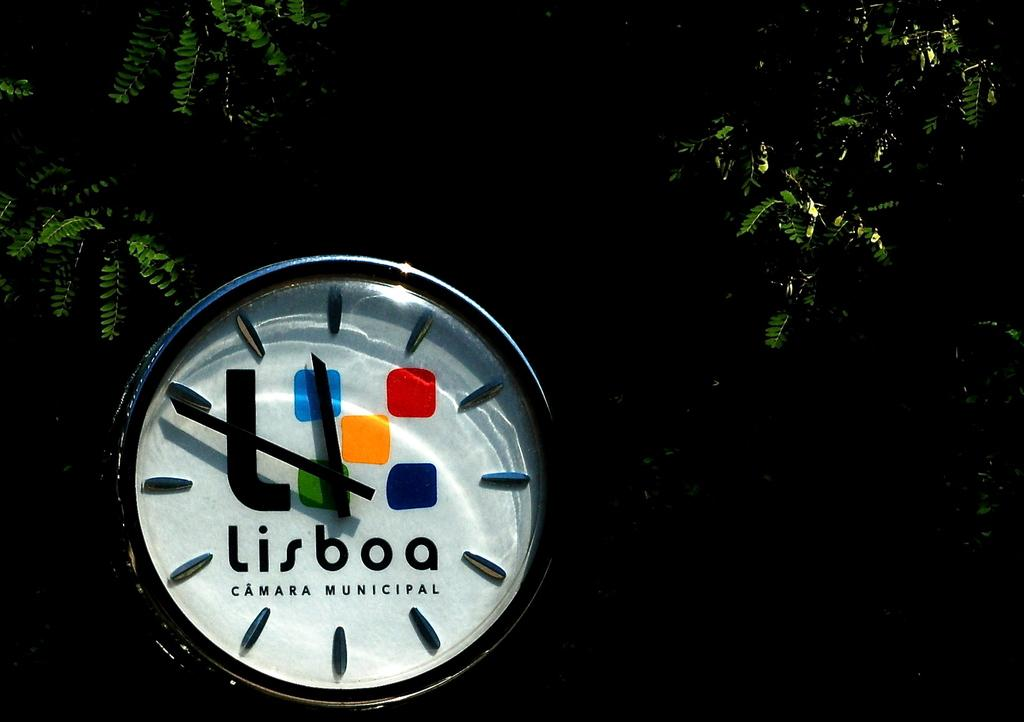<image>
Share a concise interpretation of the image provided. A clock is in the midst of tree branches and says Lisboa Camara Municipal. 